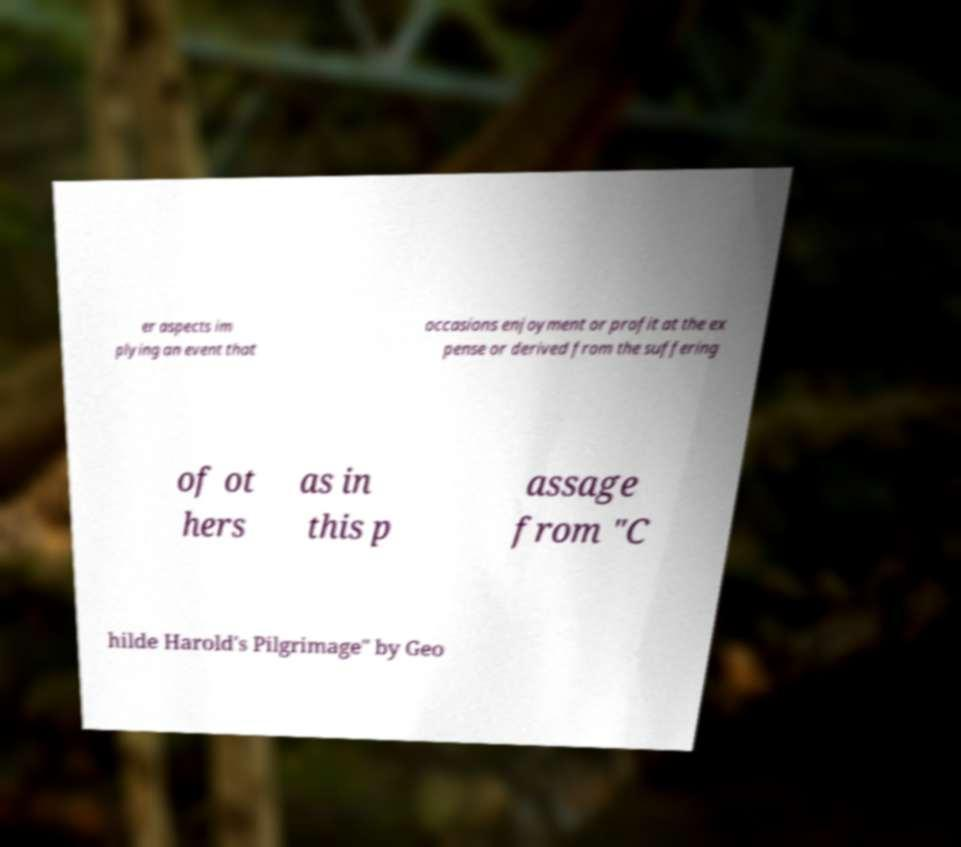Please read and relay the text visible in this image. What does it say? er aspects im plying an event that occasions enjoyment or profit at the ex pense or derived from the suffering of ot hers as in this p assage from "C hilde Harold's Pilgrimage" by Geo 